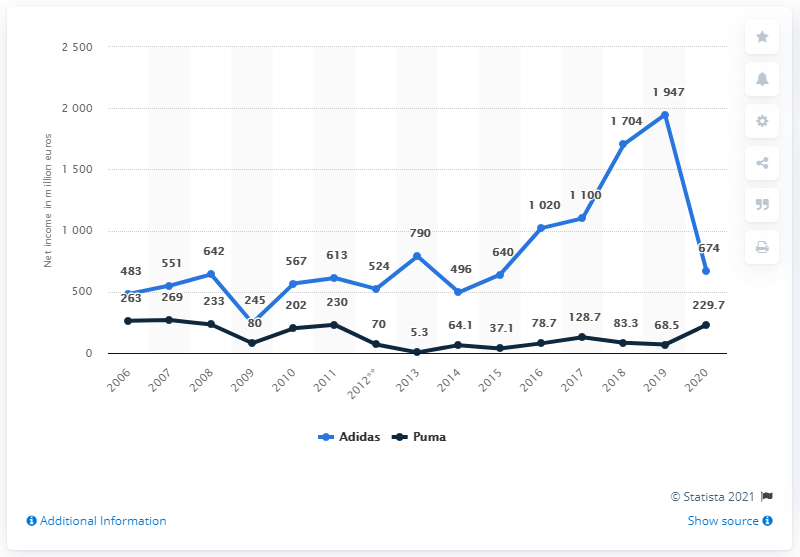Identify some key points in this picture. In 2019, the net income of Adidas was particularly high. The net income of Adidas and Puma in 2020 was 903.7 million. In 2020, Puma's net income was 229.7 million euros. 